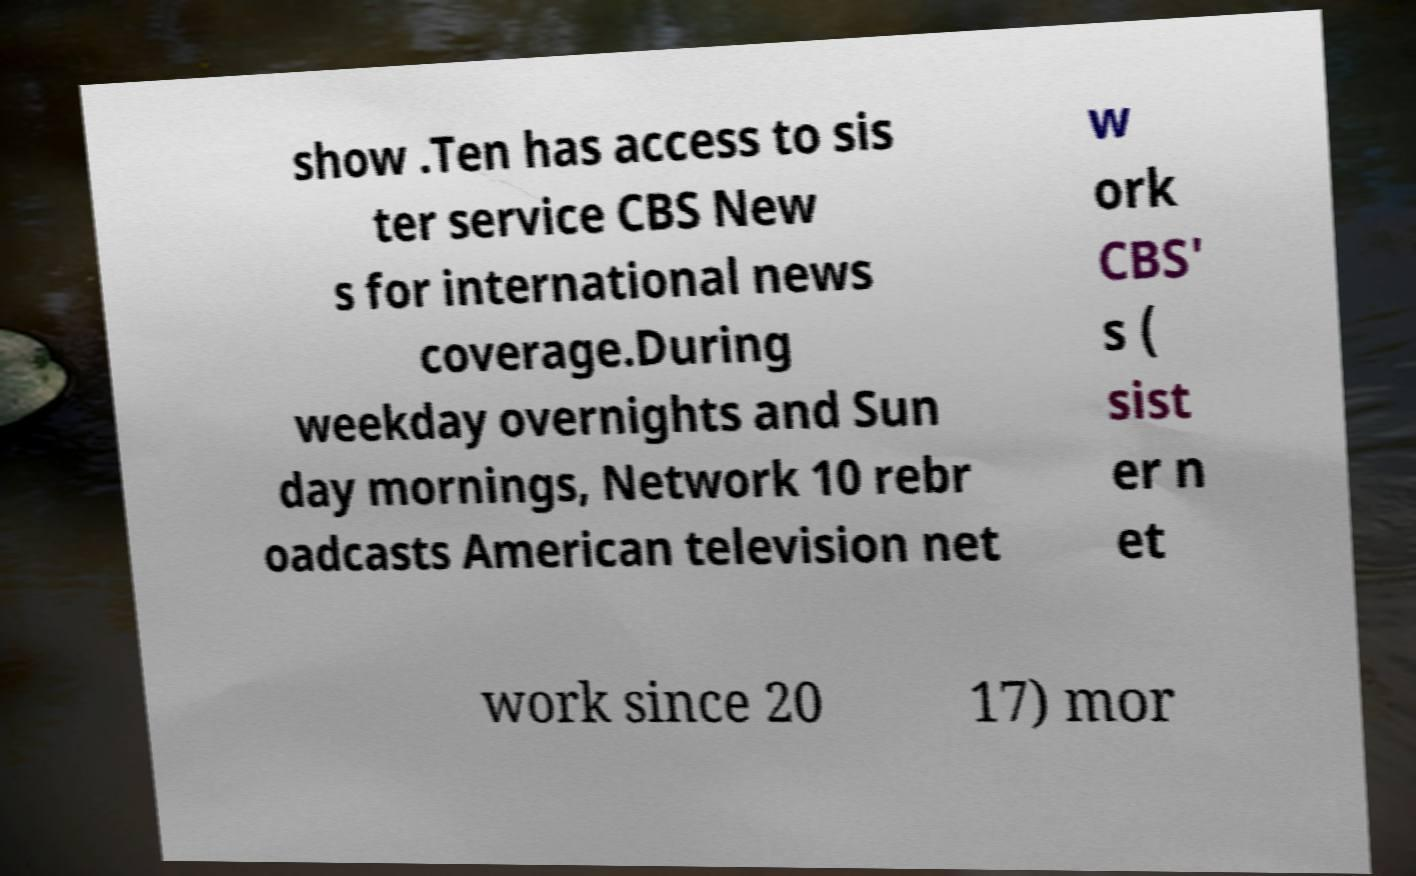Could you assist in decoding the text presented in this image and type it out clearly? show .Ten has access to sis ter service CBS New s for international news coverage.During weekday overnights and Sun day mornings, Network 10 rebr oadcasts American television net w ork CBS' s ( sist er n et work since 20 17) mor 